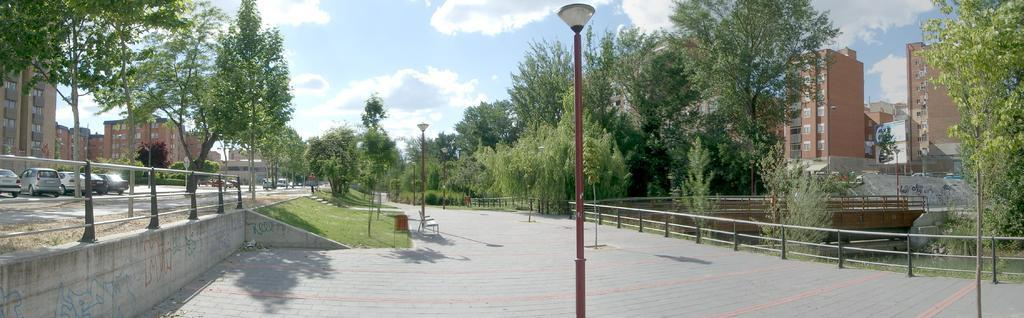What is the main structure in the center of the image? There is a lamp pole in the center of the image. What type of man-made structures can be seen in the image? There are buildings in the image. What are the boundaries in the image used for? The boundaries in the image are used to separate or define areas. What type of vegetation is present in the image? There are trees in the image. What type of transportation is visible in the image? There are vehicles in the image. What other objects can be seen in the image? There are posts in the image. Is there a person present in the image? Yes, there is a person in the image. What is visible in the background of the image? The sky is visible in the background of the image. How many kittens are playing with the person in the image? There are no kittens present in the image. What is the person in the image paying attention to? The provided facts do not give information about what the person is paying attention to. Is there a horse visible in the image? There is no horse present in the image. 